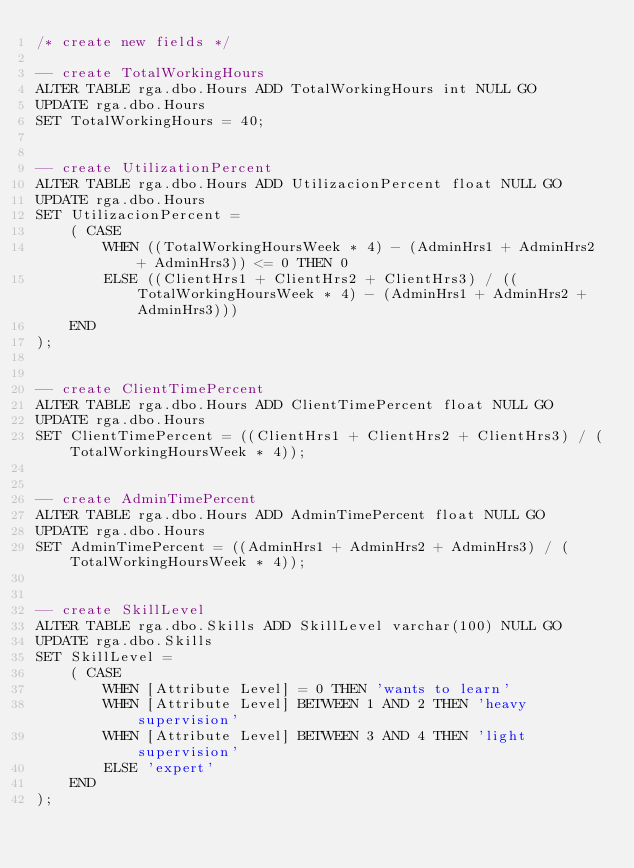<code> <loc_0><loc_0><loc_500><loc_500><_SQL_>/* create new fields */

-- create TotalWorkingHours
ALTER TABLE rga.dbo.Hours ADD TotalWorkingHours int NULL GO
UPDATE rga.dbo.Hours
SET TotalWorkingHours = 40;


-- create UtilizationPercent
ALTER TABLE rga.dbo.Hours ADD UtilizacionPercent float NULL GO
UPDATE rga.dbo.Hours
SET UtilizacionPercent =  
	( CASE 
		WHEN ((TotalWorkingHoursWeek * 4) - (AdminHrs1 + AdminHrs2 + AdminHrs3)) <= 0 THEN 0 
		ELSE ((ClientHrs1 + ClientHrs2 + ClientHrs3) / ((TotalWorkingHoursWeek * 4) - (AdminHrs1 + AdminHrs2 + AdminHrs3))) 
	END
);


-- create ClientTimePercent
ALTER TABLE rga.dbo.Hours ADD ClientTimePercent float NULL GO
UPDATE rga.dbo.Hours
SET ClientTimePercent = ((ClientHrs1 + ClientHrs2 + ClientHrs3) / (TotalWorkingHoursWeek * 4));


-- create AdminTimePercent
ALTER TABLE rga.dbo.Hours ADD AdminTimePercent float NULL GO
UPDATE rga.dbo.Hours
SET AdminTimePercent = ((AdminHrs1 + AdminHrs2 + AdminHrs3) / (TotalWorkingHoursWeek * 4));


-- create SkillLevel
ALTER TABLE rga.dbo.Skills ADD SkillLevel varchar(100) NULL GO
UPDATE rga.dbo.Skills
SET SkillLevel =  
	( CASE 
		WHEN [Attribute Level] = 0 THEN 'wants to learn'
		WHEN [Attribute Level] BETWEEN 1 AND 2 THEN 'heavy supervision'
		WHEN [Attribute Level] BETWEEN 3 AND 4 THEN 'light supervision'
		ELSE 'expert' 
	END
);

</code> 